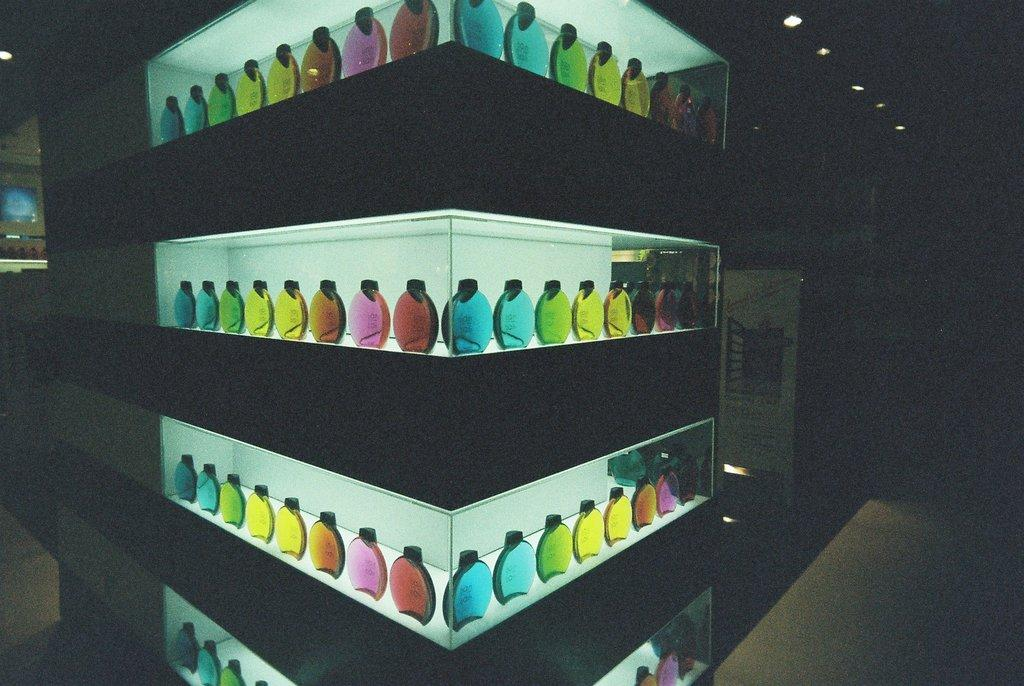What is the main subject of the image? The main subject of the image is many bottles. How are the bottles arranged in the image? The bottles are in a rack. What type of farmer is shown tending to the bottles in the image? There is no farmer present in the image, as it only features bottles in a rack. 